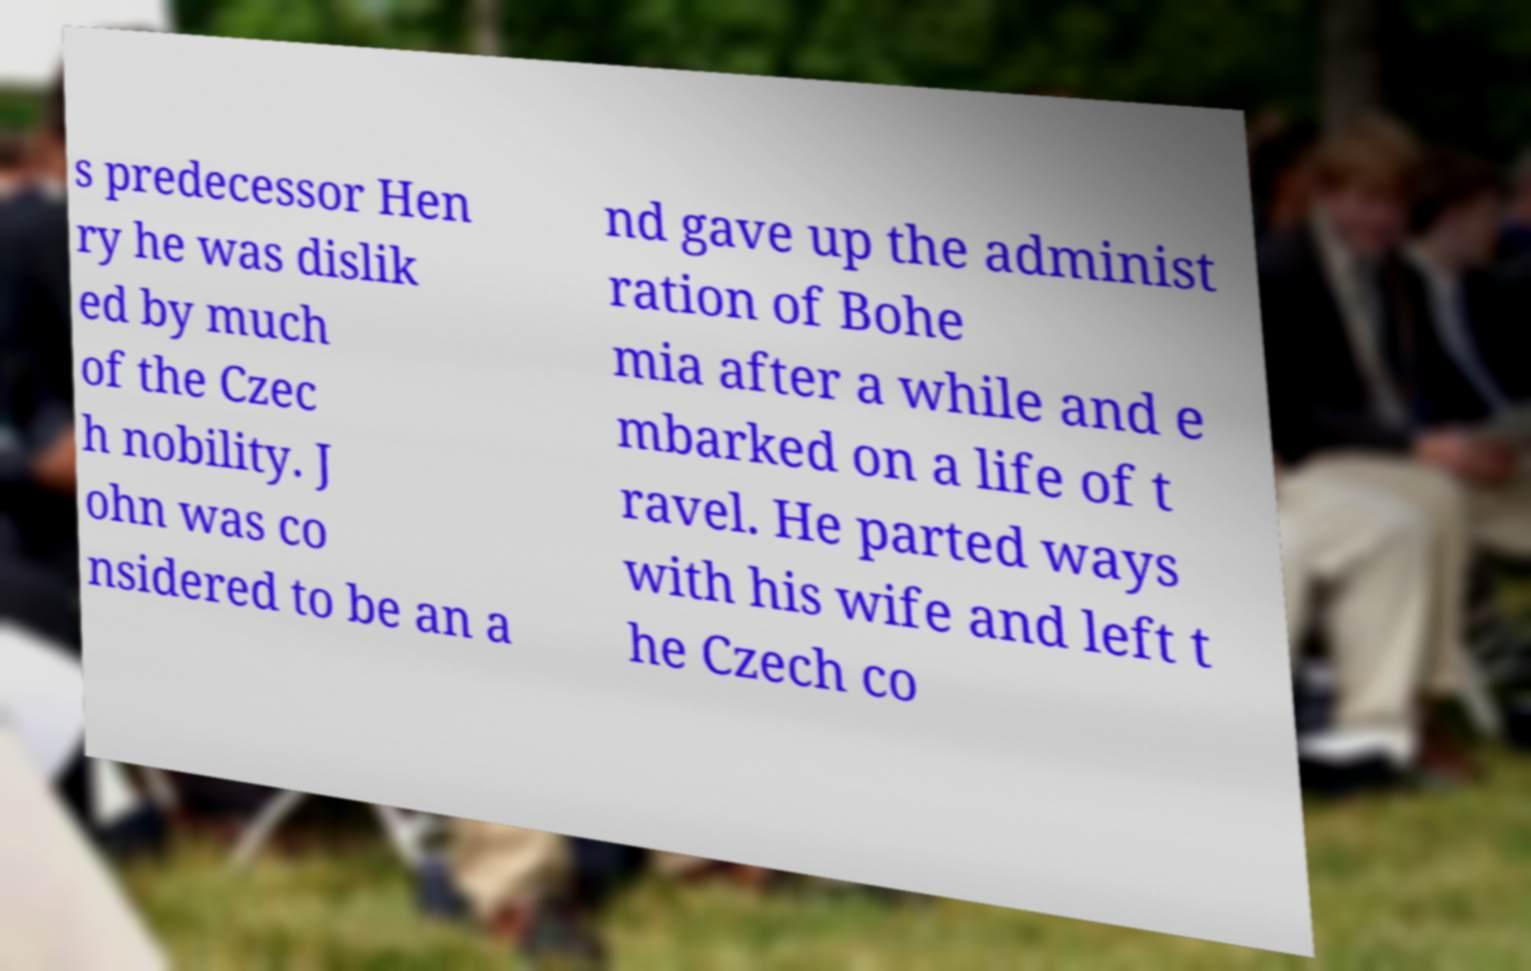I need the written content from this picture converted into text. Can you do that? s predecessor Hen ry he was dislik ed by much of the Czec h nobility. J ohn was co nsidered to be an a nd gave up the administ ration of Bohe mia after a while and e mbarked on a life of t ravel. He parted ways with his wife and left t he Czech co 